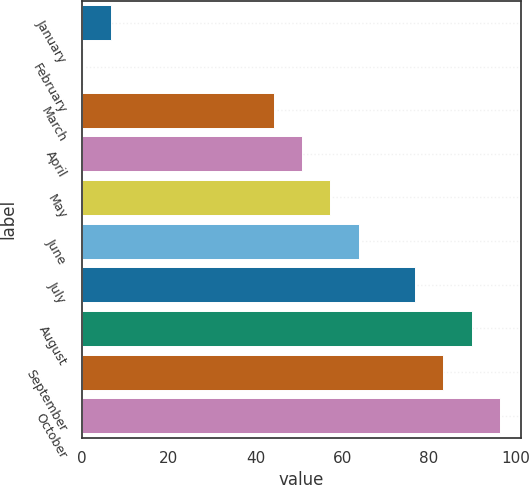Convert chart. <chart><loc_0><loc_0><loc_500><loc_500><bar_chart><fcel>January<fcel>February<fcel>March<fcel>April<fcel>May<fcel>June<fcel>July<fcel>August<fcel>September<fcel>October<nl><fcel>6.76<fcel>0.26<fcel>44.28<fcel>50.78<fcel>57.28<fcel>63.78<fcel>76.78<fcel>89.78<fcel>83.28<fcel>96.28<nl></chart> 